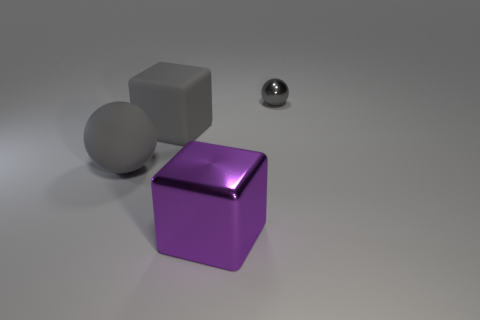Is there anything else that has the same size as the gray metallic thing?
Offer a terse response. No. What number of small gray metallic cylinders are there?
Keep it short and to the point. 0. There is a gray sphere in front of the small gray metal thing; what size is it?
Make the answer very short. Large. Is the gray cube the same size as the purple metallic block?
Make the answer very short. Yes. How many objects are either tiny yellow matte cylinders or big cubes on the left side of the large purple shiny cube?
Your answer should be very brief. 1. What material is the large purple object?
Make the answer very short. Metal. Is there anything else that has the same color as the metal ball?
Give a very brief answer. Yes. Does the big shiny thing have the same shape as the gray metallic object?
Your answer should be very brief. No. There is a rubber thing that is on the right side of the ball that is in front of the gray thing that is right of the large purple shiny block; what is its size?
Offer a very short reply. Large. What number of other objects are there of the same material as the large gray ball?
Offer a very short reply. 1. 